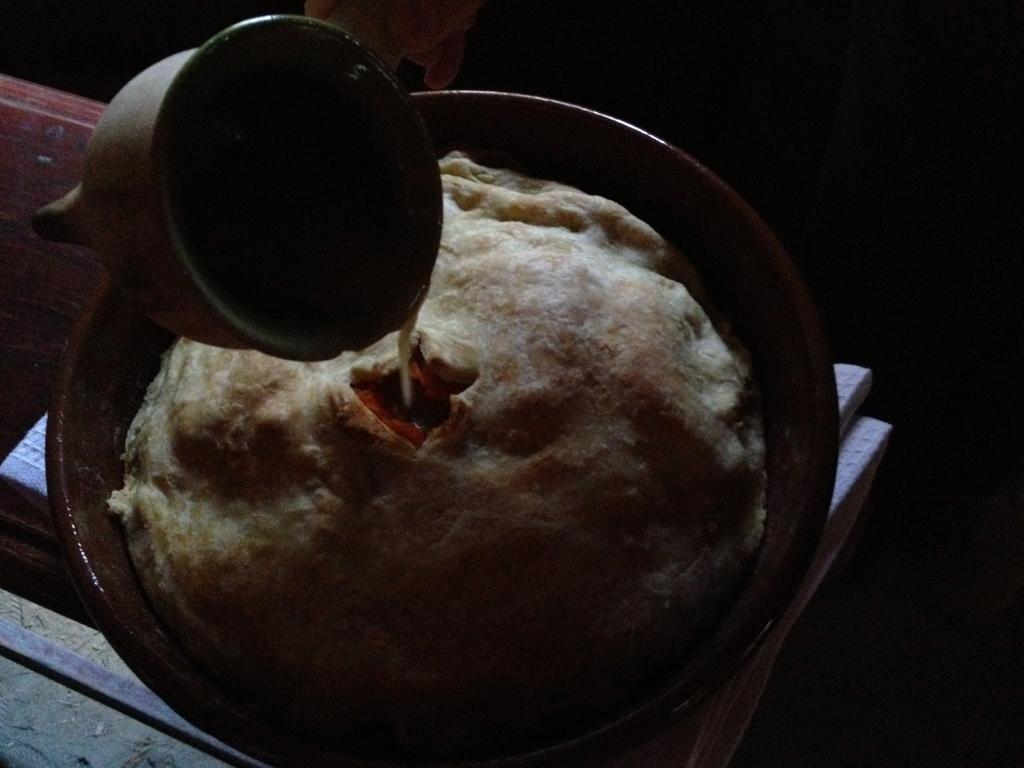What is in the bowl that is visible in the image? There is food in a bowl in the image. What is in the cup that is visible in the image? There is a liquid in a cup in the image. How many rolls of waste are visible in the image? There is no waste or rolls present in the image. Is there a turkey visible in the image? There is no turkey present in the image. 